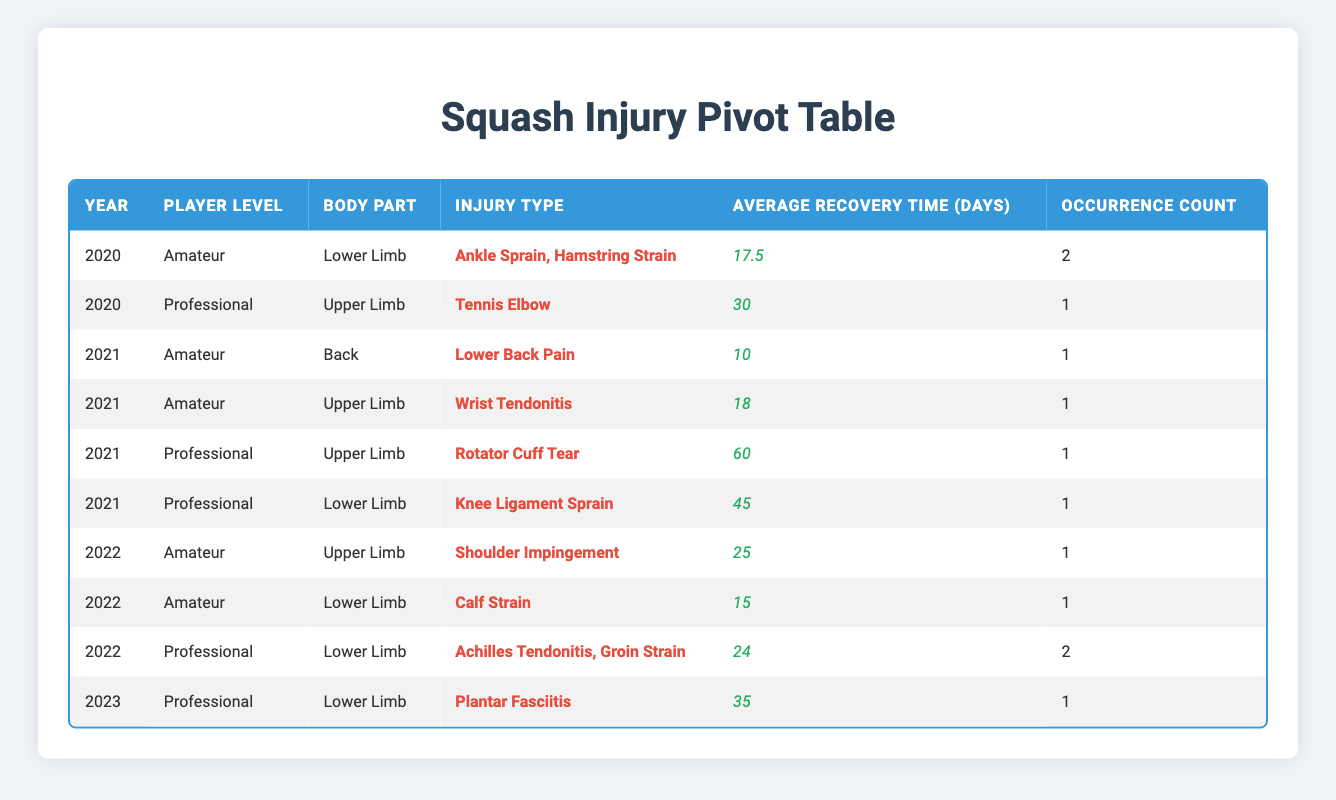What is the most common injury type among amateur players in 2020? In 2020, the amateur players reported two injury types: Ankle Sprain and Hamstring Strain. Both occurred once. Since they are equal in number, we can state that either could be considered the most common.
Answer: Ankle Sprain or Hamstring Strain Which year had the highest recorded recovery time for professional players? Examining the years, in 2021, the Rotator Cuff Tear reported a recovery time of 60 days, which is greater than any other injury type in the given years. Therefore, 2021 had the highest recorded recovery time for professional players.
Answer: 2021 How many lower limb injuries were reported among professional players in 2022? In 2022, there were two lower limb injuries reported for professional players: Achilles Tendonitis and Groin Strain, which combines to give a total count of 2.
Answer: 2 What is the average recovery time for injuries among amateur players across all years? We first sum the recovery times for amateur injuries: 14 (Ankle Sprain) + 21 (Hamstring Strain) + 10 (Lower Back Pain) + 18 (Wrist Tendonitis) + 25 (Shoulder Impingement) + 15 (Calf Strain) = 103. Then we divide by 6 (the number of injuries), resulting in an average of approximately 17.17 days.
Answer: 17.17 Is it true that there were no female professional players injured in 2020? In 2020, Sarah Johnson is the only professional player, and she is female. Therefore, the statement that there were no female professional players injured in that year is false.
Answer: No What was the total number of injuries recorded in the year 2021? The total number of injuries for every player in 2021 can be summed: Lower Back Pain (1) + Wrist Tendonitis (1) + Rotator Cuff Tear (1) + Knee Ligament Sprain (1) = 4 injuries. Hence, the total injuries recorded in 2021 were 4.
Answer: 4 Which injury type had the longest recovery time in the dataset? From the data, the Rotator Cuff Tear for professional players in 2021 had the longest recovery time of 60 days. Comparing with all other injury records, it exceeds all the rest.
Answer: Rotator Cuff Tear How many amateur injuries occurred in 2022 compared to professional injuries? In 2022, there were 2 amateur injuries (Shoulder Impingement and Calf Strain) and 2 professional injuries (Achilles Tendonitis and Groin Strain). Both categories had an equal number of injuries, so they match.
Answer: Equal (2 each) 